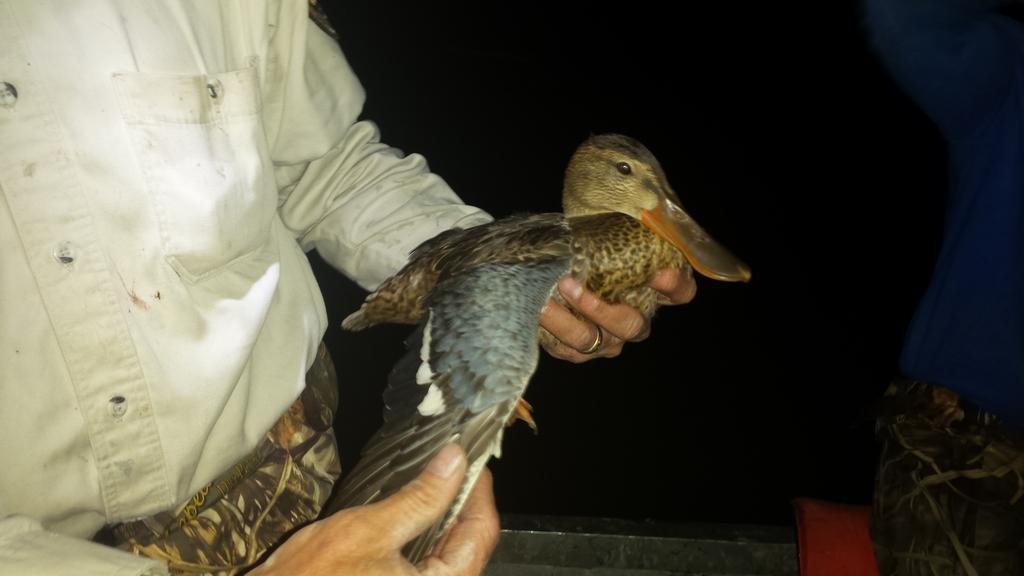Could you give a brief overview of what you see in this image? In this image I can see a person holding a bird. There is a black background. 